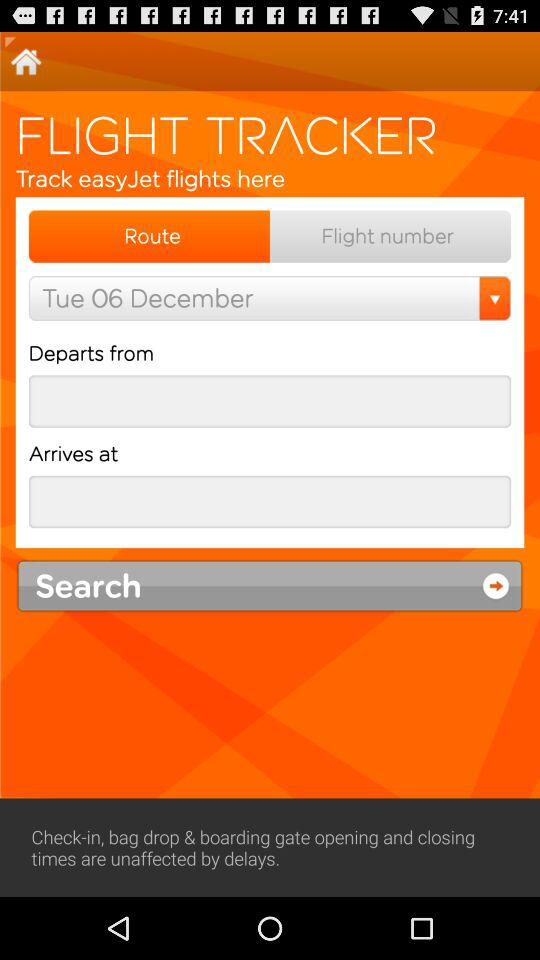Which tab am I on? You are on the "Route" tab. 